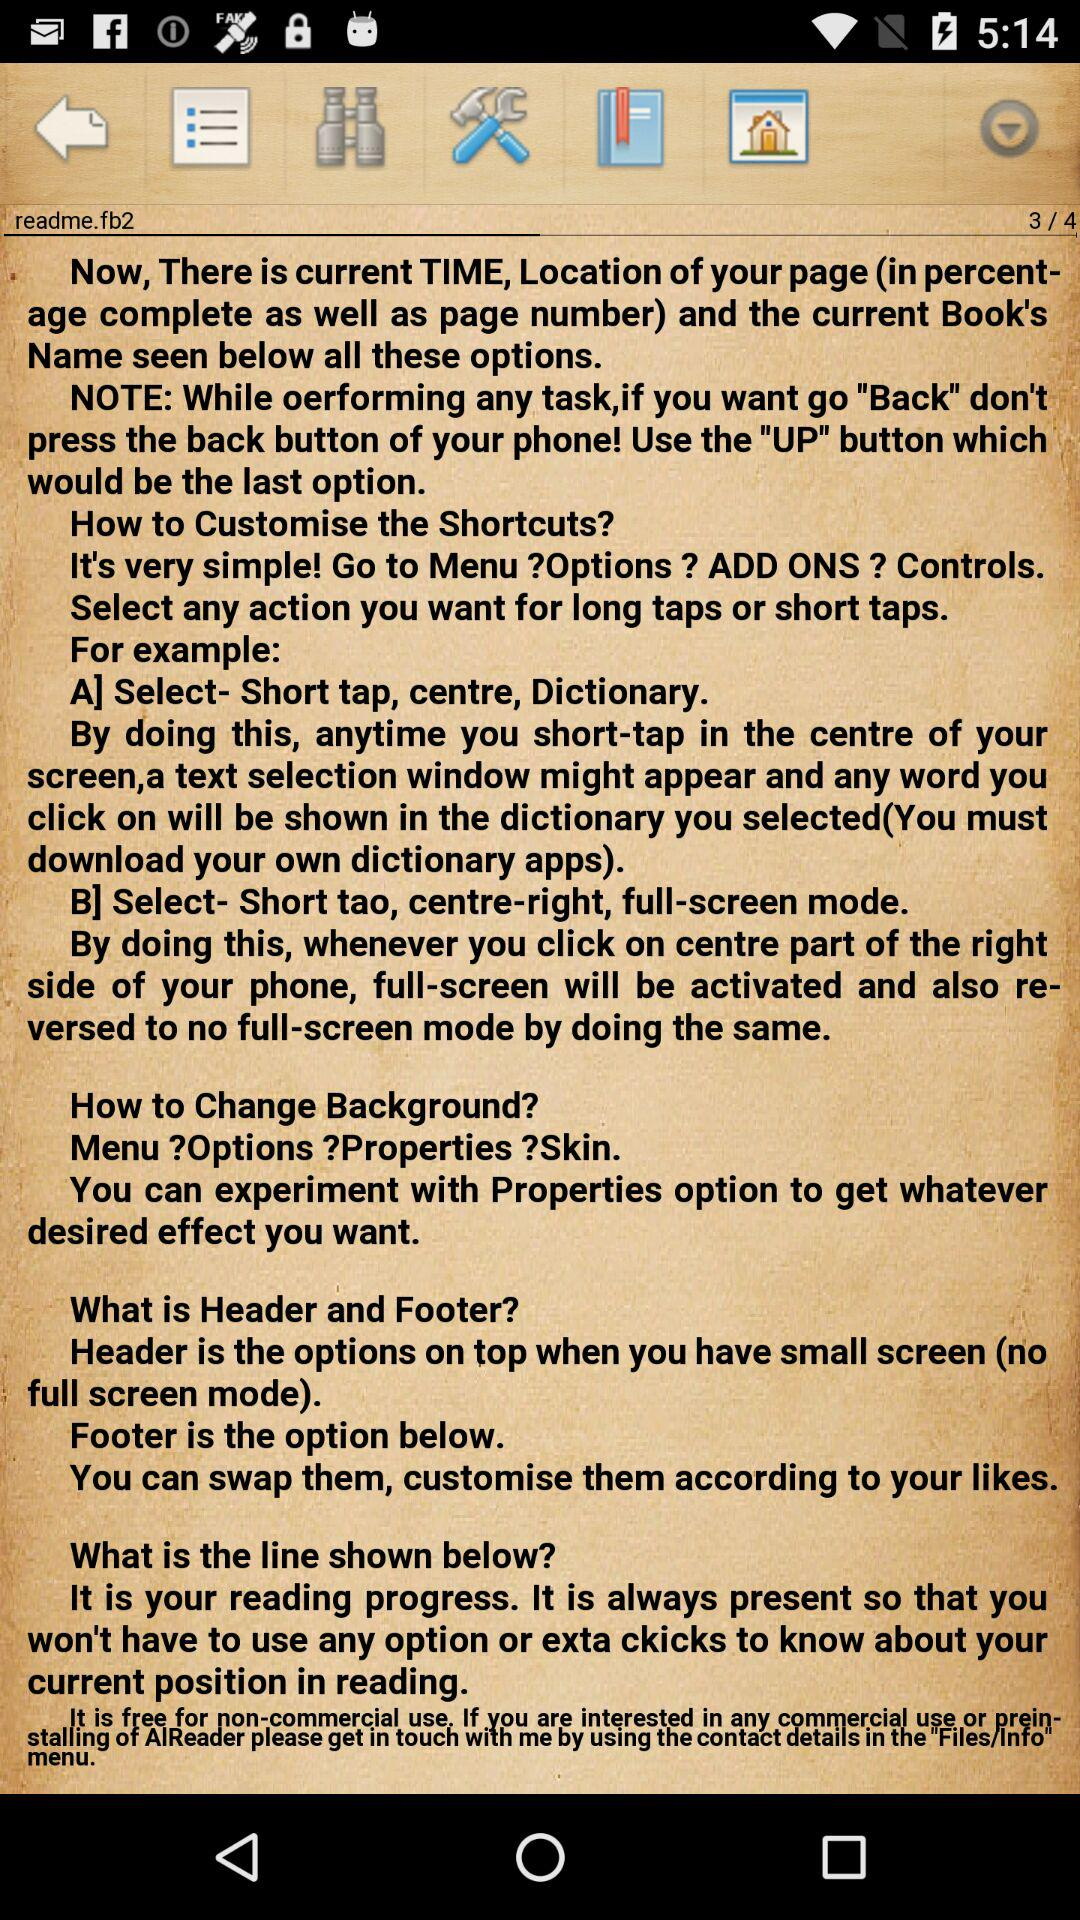Which page am I on? You are on the third page. 